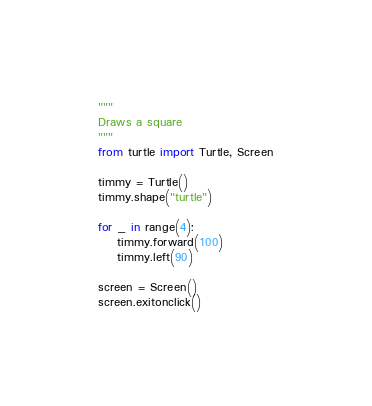Convert code to text. <code><loc_0><loc_0><loc_500><loc_500><_Python_>"""
Draws a square
"""
from turtle import Turtle, Screen

timmy = Turtle()
timmy.shape("turtle")

for _ in range(4):
    timmy.forward(100)
    timmy.left(90)

screen = Screen()
screen.exitonclick()



</code> 